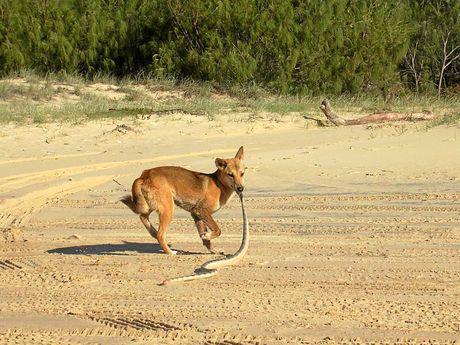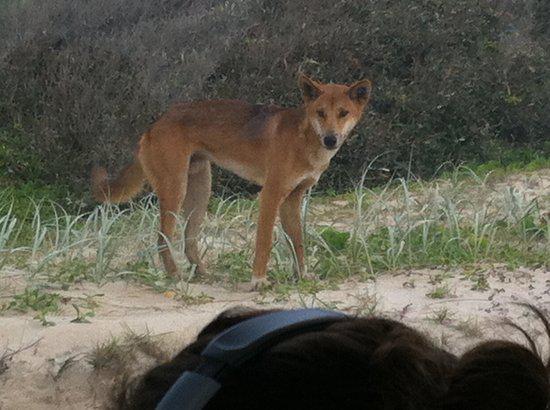The first image is the image on the left, the second image is the image on the right. For the images displayed, is the sentence "There is a dog dragging a snake over sand." factually correct? Answer yes or no. Yes. 